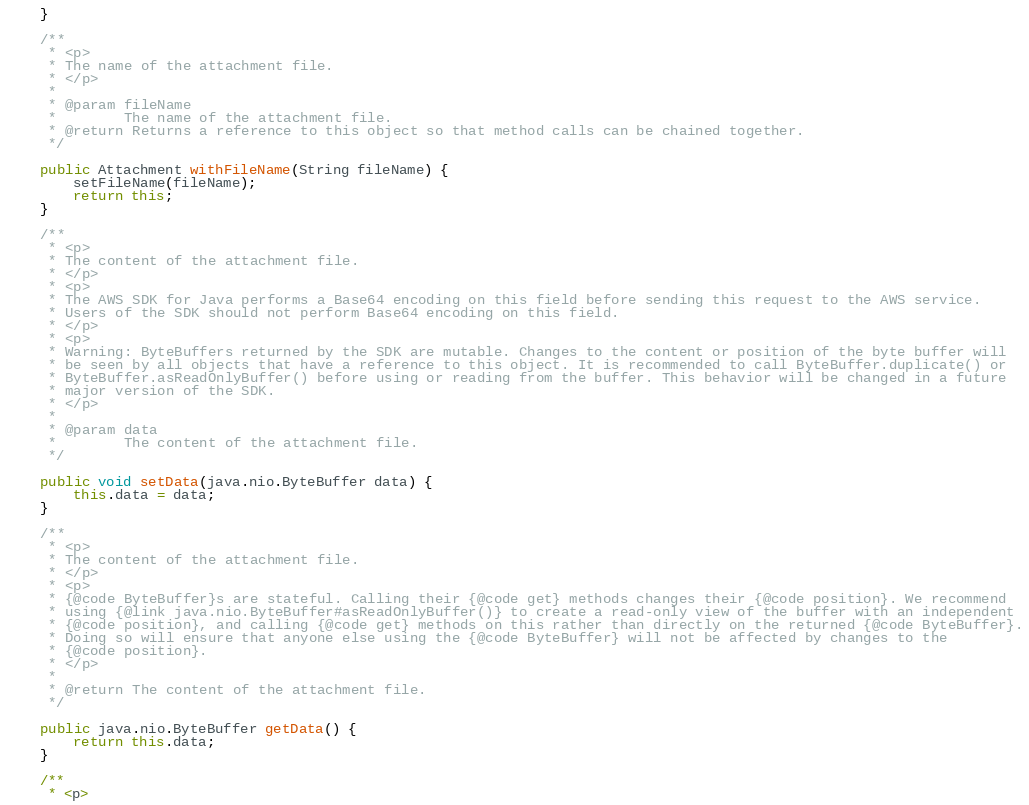<code> <loc_0><loc_0><loc_500><loc_500><_Java_>    }

    /**
     * <p>
     * The name of the attachment file.
     * </p>
     * 
     * @param fileName
     *        The name of the attachment file.
     * @return Returns a reference to this object so that method calls can be chained together.
     */

    public Attachment withFileName(String fileName) {
        setFileName(fileName);
        return this;
    }

    /**
     * <p>
     * The content of the attachment file.
     * </p>
     * <p>
     * The AWS SDK for Java performs a Base64 encoding on this field before sending this request to the AWS service.
     * Users of the SDK should not perform Base64 encoding on this field.
     * </p>
     * <p>
     * Warning: ByteBuffers returned by the SDK are mutable. Changes to the content or position of the byte buffer will
     * be seen by all objects that have a reference to this object. It is recommended to call ByteBuffer.duplicate() or
     * ByteBuffer.asReadOnlyBuffer() before using or reading from the buffer. This behavior will be changed in a future
     * major version of the SDK.
     * </p>
     * 
     * @param data
     *        The content of the attachment file.
     */

    public void setData(java.nio.ByteBuffer data) {
        this.data = data;
    }

    /**
     * <p>
     * The content of the attachment file.
     * </p>
     * <p>
     * {@code ByteBuffer}s are stateful. Calling their {@code get} methods changes their {@code position}. We recommend
     * using {@link java.nio.ByteBuffer#asReadOnlyBuffer()} to create a read-only view of the buffer with an independent
     * {@code position}, and calling {@code get} methods on this rather than directly on the returned {@code ByteBuffer}.
     * Doing so will ensure that anyone else using the {@code ByteBuffer} will not be affected by changes to the
     * {@code position}.
     * </p>
     * 
     * @return The content of the attachment file.
     */

    public java.nio.ByteBuffer getData() {
        return this.data;
    }

    /**
     * <p></code> 